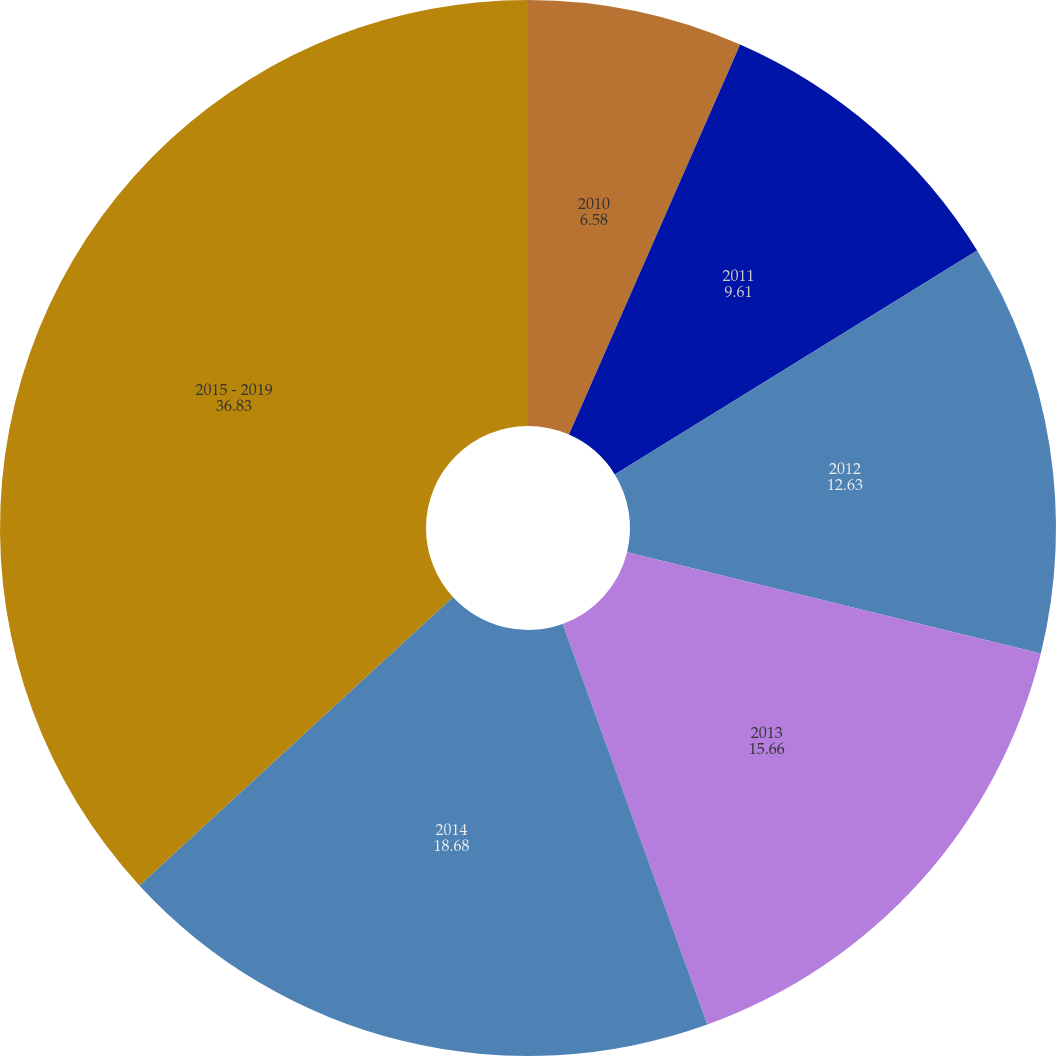Convert chart to OTSL. <chart><loc_0><loc_0><loc_500><loc_500><pie_chart><fcel>2010<fcel>2011<fcel>2012<fcel>2013<fcel>2014<fcel>2015 - 2019<nl><fcel>6.58%<fcel>9.61%<fcel>12.63%<fcel>15.66%<fcel>18.68%<fcel>36.83%<nl></chart> 